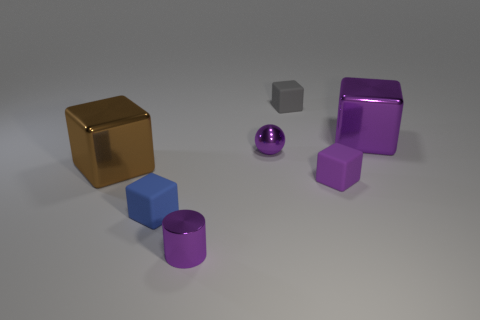Subtract all blue cylinders. How many purple blocks are left? 2 Add 3 small cyan things. How many objects exist? 10 Subtract all gray blocks. How many blocks are left? 4 Subtract all gray blocks. How many blocks are left? 4 Subtract 3 cubes. How many cubes are left? 2 Subtract all balls. How many objects are left? 6 Subtract all cyan blocks. Subtract all red spheres. How many blocks are left? 5 Add 7 cyan matte cylinders. How many cyan matte cylinders exist? 7 Subtract 0 cyan cylinders. How many objects are left? 7 Subtract all small gray things. Subtract all purple metallic balls. How many objects are left? 5 